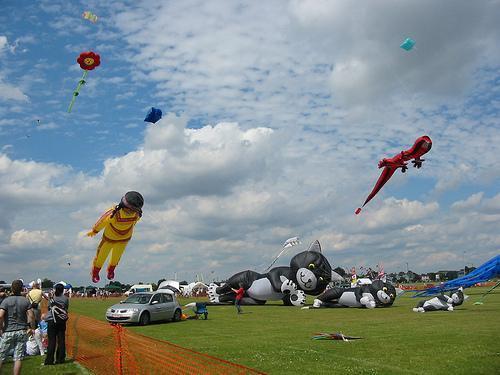How many kites are in the picture?
Give a very brief answer. 2. 